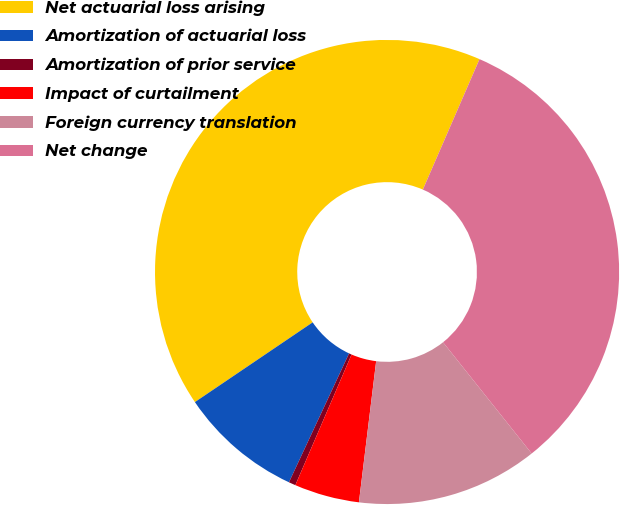Convert chart. <chart><loc_0><loc_0><loc_500><loc_500><pie_chart><fcel>Net actuarial loss arising<fcel>Amortization of actuarial loss<fcel>Amortization of prior service<fcel>Impact of curtailment<fcel>Foreign currency translation<fcel>Net change<nl><fcel>40.99%<fcel>8.58%<fcel>0.48%<fcel>4.53%<fcel>12.64%<fcel>32.77%<nl></chart> 